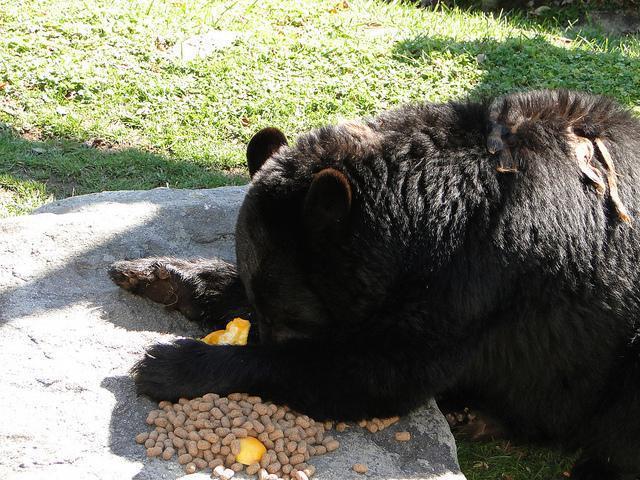How many laptops are in the picture?
Give a very brief answer. 0. 